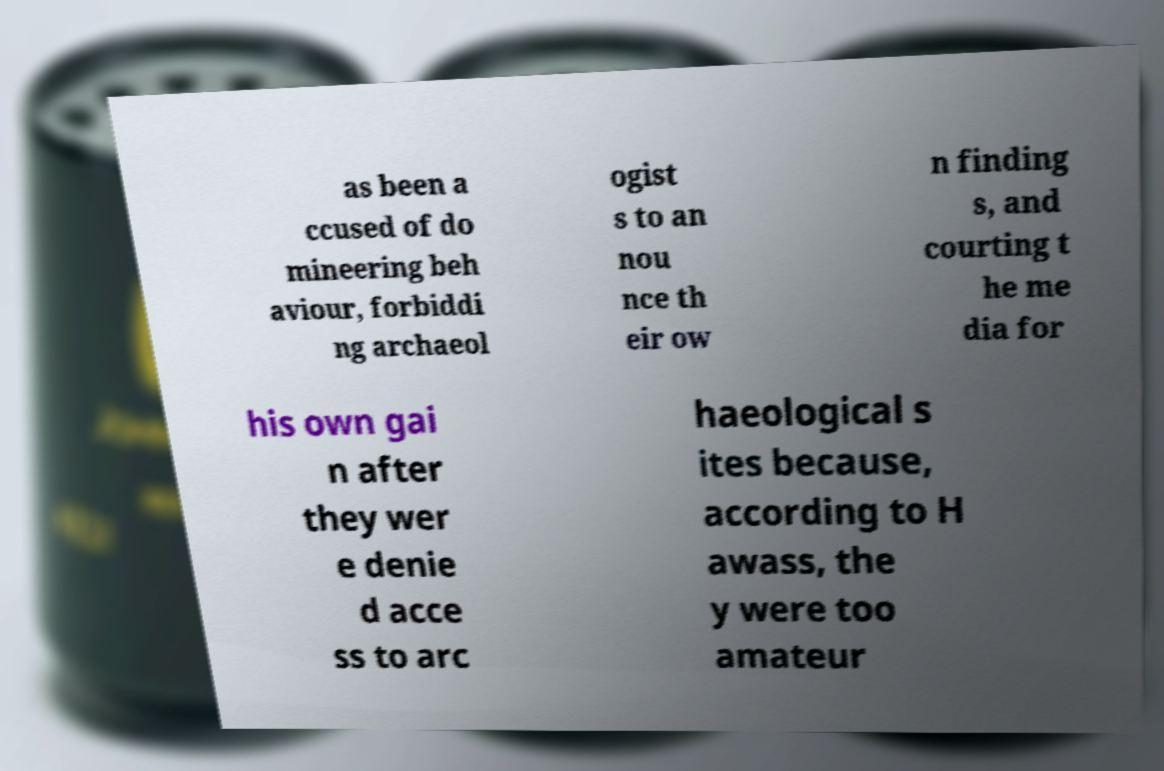I need the written content from this picture converted into text. Can you do that? as been a ccused of do mineering beh aviour, forbiddi ng archaeol ogist s to an nou nce th eir ow n finding s, and courting t he me dia for his own gai n after they wer e denie d acce ss to arc haeological s ites because, according to H awass, the y were too amateur 